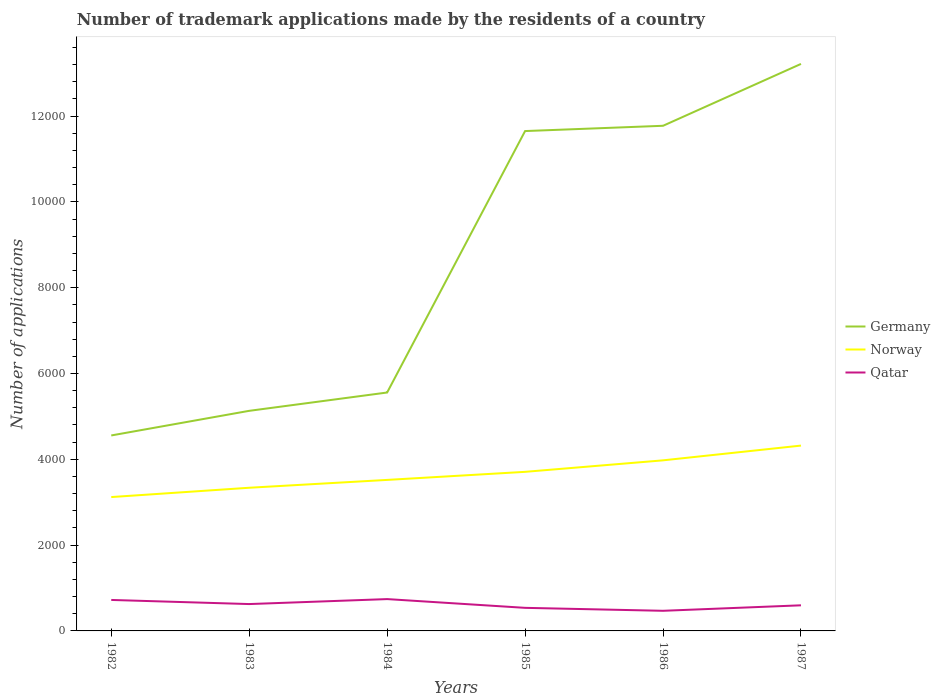How many different coloured lines are there?
Make the answer very short. 3. Is the number of lines equal to the number of legend labels?
Provide a short and direct response. Yes. Across all years, what is the maximum number of trademark applications made by the residents in Qatar?
Ensure brevity in your answer.  469. In which year was the number of trademark applications made by the residents in Germany maximum?
Make the answer very short. 1982. What is the total number of trademark applications made by the residents in Germany in the graph?
Keep it short and to the point. -1565. What is the difference between the highest and the second highest number of trademark applications made by the residents in Germany?
Offer a terse response. 8660. Is the number of trademark applications made by the residents in Qatar strictly greater than the number of trademark applications made by the residents in Norway over the years?
Give a very brief answer. Yes. Does the graph contain grids?
Offer a terse response. No. Where does the legend appear in the graph?
Your answer should be compact. Center right. How are the legend labels stacked?
Provide a short and direct response. Vertical. What is the title of the graph?
Your answer should be very brief. Number of trademark applications made by the residents of a country. Does "Barbados" appear as one of the legend labels in the graph?
Your response must be concise. No. What is the label or title of the X-axis?
Your answer should be compact. Years. What is the label or title of the Y-axis?
Your answer should be compact. Number of applications. What is the Number of applications in Germany in 1982?
Offer a terse response. 4556. What is the Number of applications of Norway in 1982?
Your answer should be very brief. 3120. What is the Number of applications of Qatar in 1982?
Ensure brevity in your answer.  722. What is the Number of applications in Germany in 1983?
Provide a succinct answer. 5130. What is the Number of applications of Norway in 1983?
Offer a very short reply. 3337. What is the Number of applications of Qatar in 1983?
Offer a very short reply. 626. What is the Number of applications in Germany in 1984?
Your answer should be very brief. 5557. What is the Number of applications in Norway in 1984?
Give a very brief answer. 3520. What is the Number of applications of Qatar in 1984?
Give a very brief answer. 742. What is the Number of applications in Germany in 1985?
Offer a very short reply. 1.17e+04. What is the Number of applications of Norway in 1985?
Make the answer very short. 3708. What is the Number of applications of Qatar in 1985?
Your answer should be very brief. 538. What is the Number of applications of Germany in 1986?
Provide a succinct answer. 1.18e+04. What is the Number of applications of Norway in 1986?
Your answer should be very brief. 3976. What is the Number of applications in Qatar in 1986?
Make the answer very short. 469. What is the Number of applications of Germany in 1987?
Give a very brief answer. 1.32e+04. What is the Number of applications of Norway in 1987?
Give a very brief answer. 4320. What is the Number of applications of Qatar in 1987?
Offer a very short reply. 597. Across all years, what is the maximum Number of applications in Germany?
Keep it short and to the point. 1.32e+04. Across all years, what is the maximum Number of applications in Norway?
Provide a short and direct response. 4320. Across all years, what is the maximum Number of applications of Qatar?
Offer a very short reply. 742. Across all years, what is the minimum Number of applications in Germany?
Give a very brief answer. 4556. Across all years, what is the minimum Number of applications of Norway?
Provide a succinct answer. 3120. Across all years, what is the minimum Number of applications of Qatar?
Offer a terse response. 469. What is the total Number of applications in Germany in the graph?
Your answer should be compact. 5.19e+04. What is the total Number of applications in Norway in the graph?
Make the answer very short. 2.20e+04. What is the total Number of applications in Qatar in the graph?
Keep it short and to the point. 3694. What is the difference between the Number of applications in Germany in 1982 and that in 1983?
Provide a short and direct response. -574. What is the difference between the Number of applications in Norway in 1982 and that in 1983?
Give a very brief answer. -217. What is the difference between the Number of applications of Qatar in 1982 and that in 1983?
Ensure brevity in your answer.  96. What is the difference between the Number of applications of Germany in 1982 and that in 1984?
Your answer should be compact. -1001. What is the difference between the Number of applications of Norway in 1982 and that in 1984?
Make the answer very short. -400. What is the difference between the Number of applications in Germany in 1982 and that in 1985?
Make the answer very short. -7095. What is the difference between the Number of applications in Norway in 1982 and that in 1985?
Provide a short and direct response. -588. What is the difference between the Number of applications in Qatar in 1982 and that in 1985?
Offer a terse response. 184. What is the difference between the Number of applications in Germany in 1982 and that in 1986?
Offer a terse response. -7218. What is the difference between the Number of applications of Norway in 1982 and that in 1986?
Ensure brevity in your answer.  -856. What is the difference between the Number of applications of Qatar in 1982 and that in 1986?
Give a very brief answer. 253. What is the difference between the Number of applications in Germany in 1982 and that in 1987?
Give a very brief answer. -8660. What is the difference between the Number of applications of Norway in 1982 and that in 1987?
Make the answer very short. -1200. What is the difference between the Number of applications in Qatar in 1982 and that in 1987?
Make the answer very short. 125. What is the difference between the Number of applications of Germany in 1983 and that in 1984?
Your answer should be very brief. -427. What is the difference between the Number of applications of Norway in 1983 and that in 1984?
Provide a succinct answer. -183. What is the difference between the Number of applications of Qatar in 1983 and that in 1984?
Your response must be concise. -116. What is the difference between the Number of applications in Germany in 1983 and that in 1985?
Keep it short and to the point. -6521. What is the difference between the Number of applications in Norway in 1983 and that in 1985?
Ensure brevity in your answer.  -371. What is the difference between the Number of applications of Qatar in 1983 and that in 1985?
Offer a very short reply. 88. What is the difference between the Number of applications of Germany in 1983 and that in 1986?
Make the answer very short. -6644. What is the difference between the Number of applications of Norway in 1983 and that in 1986?
Give a very brief answer. -639. What is the difference between the Number of applications of Qatar in 1983 and that in 1986?
Your response must be concise. 157. What is the difference between the Number of applications of Germany in 1983 and that in 1987?
Your answer should be very brief. -8086. What is the difference between the Number of applications in Norway in 1983 and that in 1987?
Offer a terse response. -983. What is the difference between the Number of applications of Qatar in 1983 and that in 1987?
Offer a terse response. 29. What is the difference between the Number of applications in Germany in 1984 and that in 1985?
Your answer should be very brief. -6094. What is the difference between the Number of applications in Norway in 1984 and that in 1985?
Provide a short and direct response. -188. What is the difference between the Number of applications of Qatar in 1984 and that in 1985?
Provide a short and direct response. 204. What is the difference between the Number of applications in Germany in 1984 and that in 1986?
Ensure brevity in your answer.  -6217. What is the difference between the Number of applications of Norway in 1984 and that in 1986?
Offer a very short reply. -456. What is the difference between the Number of applications of Qatar in 1984 and that in 1986?
Make the answer very short. 273. What is the difference between the Number of applications in Germany in 1984 and that in 1987?
Your response must be concise. -7659. What is the difference between the Number of applications of Norway in 1984 and that in 1987?
Your answer should be compact. -800. What is the difference between the Number of applications in Qatar in 1984 and that in 1987?
Offer a very short reply. 145. What is the difference between the Number of applications of Germany in 1985 and that in 1986?
Your answer should be compact. -123. What is the difference between the Number of applications of Norway in 1985 and that in 1986?
Your answer should be compact. -268. What is the difference between the Number of applications of Qatar in 1985 and that in 1986?
Ensure brevity in your answer.  69. What is the difference between the Number of applications in Germany in 1985 and that in 1987?
Provide a succinct answer. -1565. What is the difference between the Number of applications in Norway in 1985 and that in 1987?
Your answer should be very brief. -612. What is the difference between the Number of applications in Qatar in 1985 and that in 1987?
Your response must be concise. -59. What is the difference between the Number of applications of Germany in 1986 and that in 1987?
Give a very brief answer. -1442. What is the difference between the Number of applications in Norway in 1986 and that in 1987?
Keep it short and to the point. -344. What is the difference between the Number of applications in Qatar in 1986 and that in 1987?
Make the answer very short. -128. What is the difference between the Number of applications in Germany in 1982 and the Number of applications in Norway in 1983?
Keep it short and to the point. 1219. What is the difference between the Number of applications in Germany in 1982 and the Number of applications in Qatar in 1983?
Keep it short and to the point. 3930. What is the difference between the Number of applications in Norway in 1982 and the Number of applications in Qatar in 1983?
Offer a terse response. 2494. What is the difference between the Number of applications in Germany in 1982 and the Number of applications in Norway in 1984?
Provide a short and direct response. 1036. What is the difference between the Number of applications in Germany in 1982 and the Number of applications in Qatar in 1984?
Offer a very short reply. 3814. What is the difference between the Number of applications of Norway in 1982 and the Number of applications of Qatar in 1984?
Ensure brevity in your answer.  2378. What is the difference between the Number of applications in Germany in 1982 and the Number of applications in Norway in 1985?
Keep it short and to the point. 848. What is the difference between the Number of applications of Germany in 1982 and the Number of applications of Qatar in 1985?
Your response must be concise. 4018. What is the difference between the Number of applications in Norway in 1982 and the Number of applications in Qatar in 1985?
Provide a short and direct response. 2582. What is the difference between the Number of applications in Germany in 1982 and the Number of applications in Norway in 1986?
Provide a succinct answer. 580. What is the difference between the Number of applications in Germany in 1982 and the Number of applications in Qatar in 1986?
Give a very brief answer. 4087. What is the difference between the Number of applications of Norway in 1982 and the Number of applications of Qatar in 1986?
Ensure brevity in your answer.  2651. What is the difference between the Number of applications in Germany in 1982 and the Number of applications in Norway in 1987?
Make the answer very short. 236. What is the difference between the Number of applications in Germany in 1982 and the Number of applications in Qatar in 1987?
Make the answer very short. 3959. What is the difference between the Number of applications of Norway in 1982 and the Number of applications of Qatar in 1987?
Provide a short and direct response. 2523. What is the difference between the Number of applications in Germany in 1983 and the Number of applications in Norway in 1984?
Ensure brevity in your answer.  1610. What is the difference between the Number of applications of Germany in 1983 and the Number of applications of Qatar in 1984?
Make the answer very short. 4388. What is the difference between the Number of applications of Norway in 1983 and the Number of applications of Qatar in 1984?
Make the answer very short. 2595. What is the difference between the Number of applications of Germany in 1983 and the Number of applications of Norway in 1985?
Keep it short and to the point. 1422. What is the difference between the Number of applications in Germany in 1983 and the Number of applications in Qatar in 1985?
Make the answer very short. 4592. What is the difference between the Number of applications of Norway in 1983 and the Number of applications of Qatar in 1985?
Make the answer very short. 2799. What is the difference between the Number of applications of Germany in 1983 and the Number of applications of Norway in 1986?
Provide a short and direct response. 1154. What is the difference between the Number of applications in Germany in 1983 and the Number of applications in Qatar in 1986?
Your answer should be compact. 4661. What is the difference between the Number of applications in Norway in 1983 and the Number of applications in Qatar in 1986?
Make the answer very short. 2868. What is the difference between the Number of applications of Germany in 1983 and the Number of applications of Norway in 1987?
Keep it short and to the point. 810. What is the difference between the Number of applications of Germany in 1983 and the Number of applications of Qatar in 1987?
Your response must be concise. 4533. What is the difference between the Number of applications of Norway in 1983 and the Number of applications of Qatar in 1987?
Your answer should be very brief. 2740. What is the difference between the Number of applications of Germany in 1984 and the Number of applications of Norway in 1985?
Offer a very short reply. 1849. What is the difference between the Number of applications of Germany in 1984 and the Number of applications of Qatar in 1985?
Ensure brevity in your answer.  5019. What is the difference between the Number of applications in Norway in 1984 and the Number of applications in Qatar in 1985?
Your response must be concise. 2982. What is the difference between the Number of applications in Germany in 1984 and the Number of applications in Norway in 1986?
Provide a short and direct response. 1581. What is the difference between the Number of applications of Germany in 1984 and the Number of applications of Qatar in 1986?
Offer a very short reply. 5088. What is the difference between the Number of applications of Norway in 1984 and the Number of applications of Qatar in 1986?
Give a very brief answer. 3051. What is the difference between the Number of applications in Germany in 1984 and the Number of applications in Norway in 1987?
Make the answer very short. 1237. What is the difference between the Number of applications of Germany in 1984 and the Number of applications of Qatar in 1987?
Provide a succinct answer. 4960. What is the difference between the Number of applications in Norway in 1984 and the Number of applications in Qatar in 1987?
Provide a succinct answer. 2923. What is the difference between the Number of applications of Germany in 1985 and the Number of applications of Norway in 1986?
Offer a terse response. 7675. What is the difference between the Number of applications of Germany in 1985 and the Number of applications of Qatar in 1986?
Provide a short and direct response. 1.12e+04. What is the difference between the Number of applications in Norway in 1985 and the Number of applications in Qatar in 1986?
Your answer should be compact. 3239. What is the difference between the Number of applications of Germany in 1985 and the Number of applications of Norway in 1987?
Provide a short and direct response. 7331. What is the difference between the Number of applications in Germany in 1985 and the Number of applications in Qatar in 1987?
Your response must be concise. 1.11e+04. What is the difference between the Number of applications in Norway in 1985 and the Number of applications in Qatar in 1987?
Provide a short and direct response. 3111. What is the difference between the Number of applications in Germany in 1986 and the Number of applications in Norway in 1987?
Give a very brief answer. 7454. What is the difference between the Number of applications in Germany in 1986 and the Number of applications in Qatar in 1987?
Ensure brevity in your answer.  1.12e+04. What is the difference between the Number of applications of Norway in 1986 and the Number of applications of Qatar in 1987?
Make the answer very short. 3379. What is the average Number of applications of Germany per year?
Keep it short and to the point. 8647.33. What is the average Number of applications in Norway per year?
Your answer should be very brief. 3663.5. What is the average Number of applications in Qatar per year?
Keep it short and to the point. 615.67. In the year 1982, what is the difference between the Number of applications in Germany and Number of applications in Norway?
Give a very brief answer. 1436. In the year 1982, what is the difference between the Number of applications in Germany and Number of applications in Qatar?
Ensure brevity in your answer.  3834. In the year 1982, what is the difference between the Number of applications of Norway and Number of applications of Qatar?
Keep it short and to the point. 2398. In the year 1983, what is the difference between the Number of applications in Germany and Number of applications in Norway?
Make the answer very short. 1793. In the year 1983, what is the difference between the Number of applications in Germany and Number of applications in Qatar?
Provide a succinct answer. 4504. In the year 1983, what is the difference between the Number of applications in Norway and Number of applications in Qatar?
Offer a very short reply. 2711. In the year 1984, what is the difference between the Number of applications in Germany and Number of applications in Norway?
Provide a short and direct response. 2037. In the year 1984, what is the difference between the Number of applications in Germany and Number of applications in Qatar?
Provide a short and direct response. 4815. In the year 1984, what is the difference between the Number of applications in Norway and Number of applications in Qatar?
Your answer should be compact. 2778. In the year 1985, what is the difference between the Number of applications of Germany and Number of applications of Norway?
Ensure brevity in your answer.  7943. In the year 1985, what is the difference between the Number of applications of Germany and Number of applications of Qatar?
Give a very brief answer. 1.11e+04. In the year 1985, what is the difference between the Number of applications in Norway and Number of applications in Qatar?
Keep it short and to the point. 3170. In the year 1986, what is the difference between the Number of applications in Germany and Number of applications in Norway?
Make the answer very short. 7798. In the year 1986, what is the difference between the Number of applications of Germany and Number of applications of Qatar?
Provide a short and direct response. 1.13e+04. In the year 1986, what is the difference between the Number of applications in Norway and Number of applications in Qatar?
Give a very brief answer. 3507. In the year 1987, what is the difference between the Number of applications of Germany and Number of applications of Norway?
Your answer should be compact. 8896. In the year 1987, what is the difference between the Number of applications in Germany and Number of applications in Qatar?
Your response must be concise. 1.26e+04. In the year 1987, what is the difference between the Number of applications of Norway and Number of applications of Qatar?
Your answer should be compact. 3723. What is the ratio of the Number of applications in Germany in 1982 to that in 1983?
Provide a succinct answer. 0.89. What is the ratio of the Number of applications of Norway in 1982 to that in 1983?
Your answer should be compact. 0.94. What is the ratio of the Number of applications in Qatar in 1982 to that in 1983?
Ensure brevity in your answer.  1.15. What is the ratio of the Number of applications in Germany in 1982 to that in 1984?
Your answer should be compact. 0.82. What is the ratio of the Number of applications in Norway in 1982 to that in 1984?
Offer a terse response. 0.89. What is the ratio of the Number of applications of Germany in 1982 to that in 1985?
Provide a succinct answer. 0.39. What is the ratio of the Number of applications in Norway in 1982 to that in 1985?
Provide a short and direct response. 0.84. What is the ratio of the Number of applications in Qatar in 1982 to that in 1985?
Ensure brevity in your answer.  1.34. What is the ratio of the Number of applications in Germany in 1982 to that in 1986?
Offer a very short reply. 0.39. What is the ratio of the Number of applications of Norway in 1982 to that in 1986?
Make the answer very short. 0.78. What is the ratio of the Number of applications in Qatar in 1982 to that in 1986?
Offer a very short reply. 1.54. What is the ratio of the Number of applications of Germany in 1982 to that in 1987?
Provide a short and direct response. 0.34. What is the ratio of the Number of applications of Norway in 1982 to that in 1987?
Offer a very short reply. 0.72. What is the ratio of the Number of applications in Qatar in 1982 to that in 1987?
Offer a very short reply. 1.21. What is the ratio of the Number of applications of Germany in 1983 to that in 1984?
Your answer should be very brief. 0.92. What is the ratio of the Number of applications of Norway in 1983 to that in 1984?
Provide a short and direct response. 0.95. What is the ratio of the Number of applications of Qatar in 1983 to that in 1984?
Your response must be concise. 0.84. What is the ratio of the Number of applications of Germany in 1983 to that in 1985?
Offer a terse response. 0.44. What is the ratio of the Number of applications of Norway in 1983 to that in 1985?
Your response must be concise. 0.9. What is the ratio of the Number of applications in Qatar in 1983 to that in 1985?
Offer a terse response. 1.16. What is the ratio of the Number of applications of Germany in 1983 to that in 1986?
Offer a terse response. 0.44. What is the ratio of the Number of applications of Norway in 1983 to that in 1986?
Offer a terse response. 0.84. What is the ratio of the Number of applications of Qatar in 1983 to that in 1986?
Make the answer very short. 1.33. What is the ratio of the Number of applications in Germany in 1983 to that in 1987?
Offer a very short reply. 0.39. What is the ratio of the Number of applications of Norway in 1983 to that in 1987?
Keep it short and to the point. 0.77. What is the ratio of the Number of applications of Qatar in 1983 to that in 1987?
Keep it short and to the point. 1.05. What is the ratio of the Number of applications in Germany in 1984 to that in 1985?
Make the answer very short. 0.48. What is the ratio of the Number of applications in Norway in 1984 to that in 1985?
Provide a short and direct response. 0.95. What is the ratio of the Number of applications in Qatar in 1984 to that in 1985?
Offer a terse response. 1.38. What is the ratio of the Number of applications of Germany in 1984 to that in 1986?
Give a very brief answer. 0.47. What is the ratio of the Number of applications in Norway in 1984 to that in 1986?
Make the answer very short. 0.89. What is the ratio of the Number of applications in Qatar in 1984 to that in 1986?
Offer a very short reply. 1.58. What is the ratio of the Number of applications of Germany in 1984 to that in 1987?
Your response must be concise. 0.42. What is the ratio of the Number of applications of Norway in 1984 to that in 1987?
Ensure brevity in your answer.  0.81. What is the ratio of the Number of applications in Qatar in 1984 to that in 1987?
Your response must be concise. 1.24. What is the ratio of the Number of applications of Germany in 1985 to that in 1986?
Give a very brief answer. 0.99. What is the ratio of the Number of applications of Norway in 1985 to that in 1986?
Your response must be concise. 0.93. What is the ratio of the Number of applications of Qatar in 1985 to that in 1986?
Keep it short and to the point. 1.15. What is the ratio of the Number of applications in Germany in 1985 to that in 1987?
Keep it short and to the point. 0.88. What is the ratio of the Number of applications of Norway in 1985 to that in 1987?
Your response must be concise. 0.86. What is the ratio of the Number of applications of Qatar in 1985 to that in 1987?
Your response must be concise. 0.9. What is the ratio of the Number of applications of Germany in 1986 to that in 1987?
Make the answer very short. 0.89. What is the ratio of the Number of applications in Norway in 1986 to that in 1987?
Offer a very short reply. 0.92. What is the ratio of the Number of applications of Qatar in 1986 to that in 1987?
Make the answer very short. 0.79. What is the difference between the highest and the second highest Number of applications in Germany?
Offer a very short reply. 1442. What is the difference between the highest and the second highest Number of applications in Norway?
Provide a succinct answer. 344. What is the difference between the highest and the lowest Number of applications in Germany?
Ensure brevity in your answer.  8660. What is the difference between the highest and the lowest Number of applications in Norway?
Provide a short and direct response. 1200. What is the difference between the highest and the lowest Number of applications in Qatar?
Provide a succinct answer. 273. 